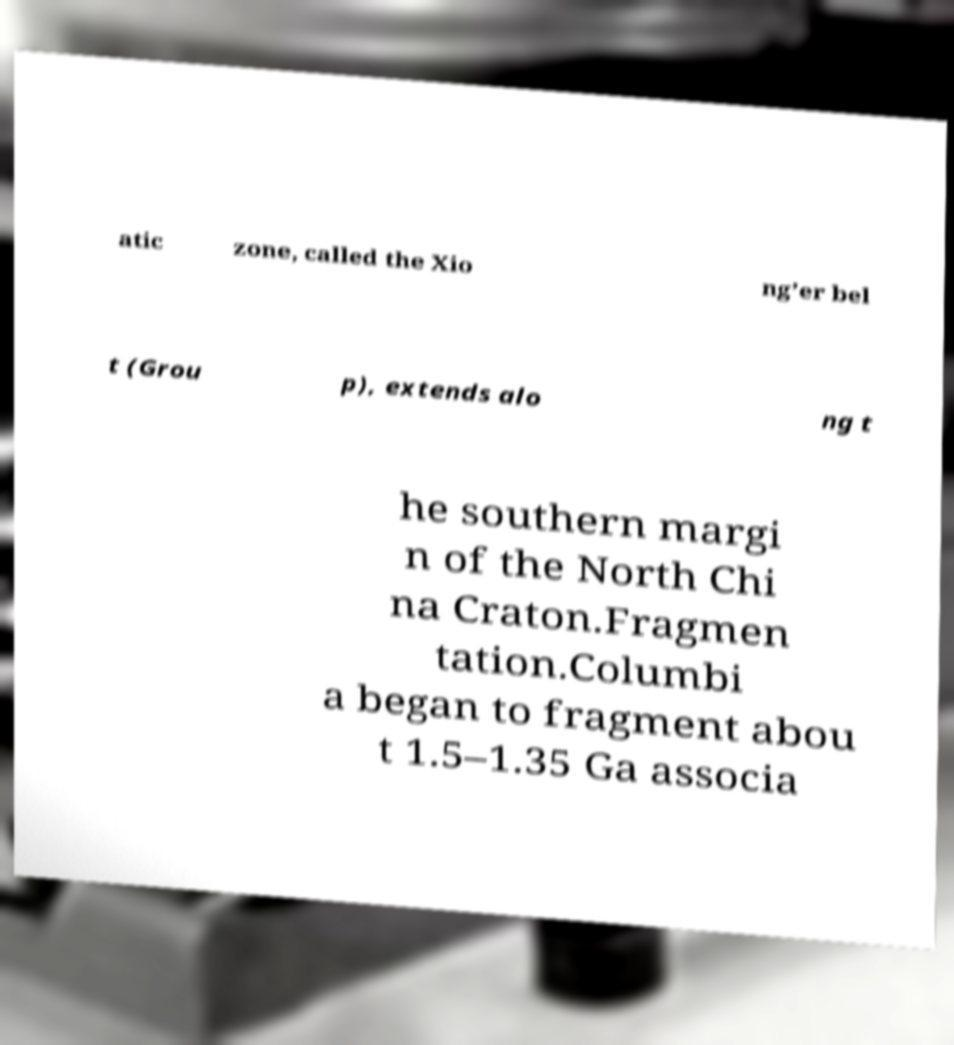Could you extract and type out the text from this image? atic zone, called the Xio ng’er bel t (Grou p), extends alo ng t he southern margi n of the North Chi na Craton.Fragmen tation.Columbi a began to fragment abou t 1.5–1.35 Ga associa 